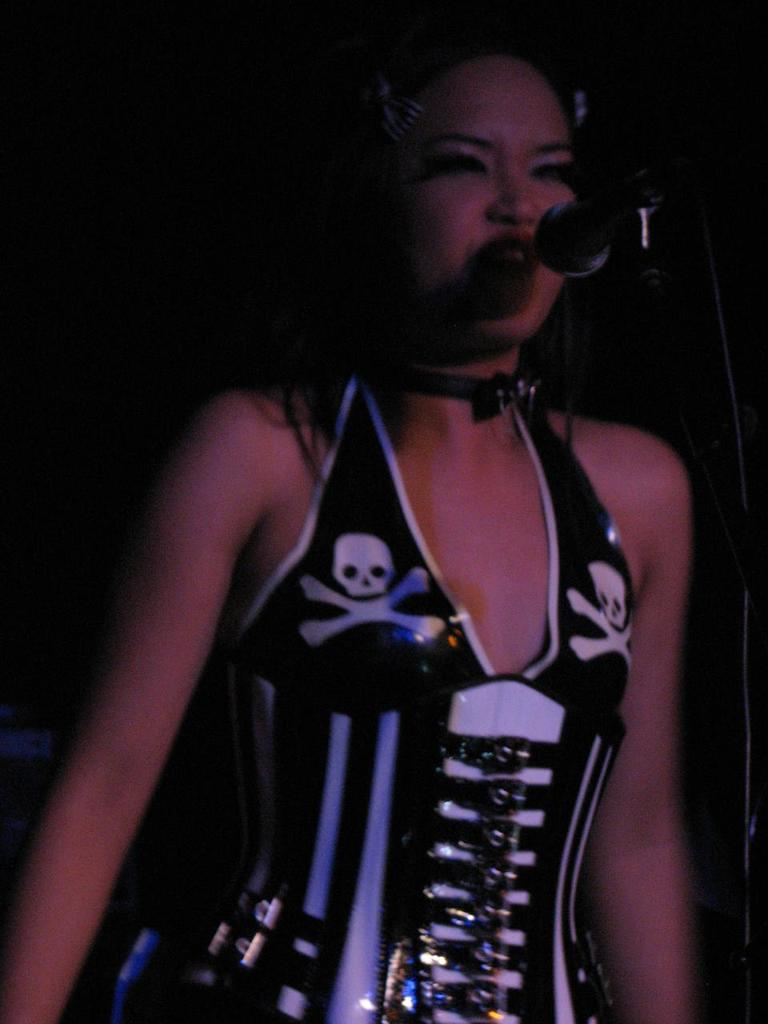Who is the main subject in the image? There is a woman in the image. What object is in front of the woman? There is a mic in front of the woman. What can be observed about the background of the image? The background of the image is dark. How many snakes are visible in the image? There are no snakes present in the image. What is the girl doing in the image? There is no girl present in the image; the main subject is a woman. 